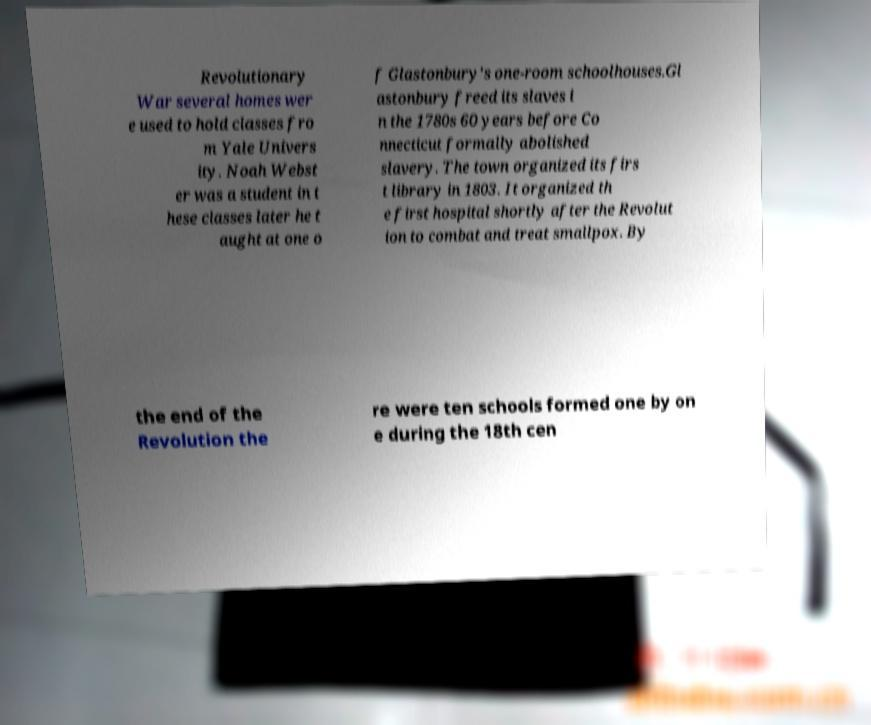For documentation purposes, I need the text within this image transcribed. Could you provide that? Revolutionary War several homes wer e used to hold classes fro m Yale Univers ity. Noah Webst er was a student in t hese classes later he t aught at one o f Glastonbury's one-room schoolhouses.Gl astonbury freed its slaves i n the 1780s 60 years before Co nnecticut formally abolished slavery. The town organized its firs t library in 1803. It organized th e first hospital shortly after the Revolut ion to combat and treat smallpox. By the end of the Revolution the re were ten schools formed one by on e during the 18th cen 